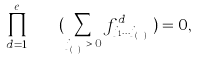<formula> <loc_0><loc_0><loc_500><loc_500>\prod _ { d = 1 } ^ { e } \quad ( \sum _ { j _ { ( i ^ { d } ) } \, > \, 0 } f ^ { d } _ { { j _ { 1 } } \dots { j _ { ( k ^ { d } ) } } } ) = 0 ,</formula> 